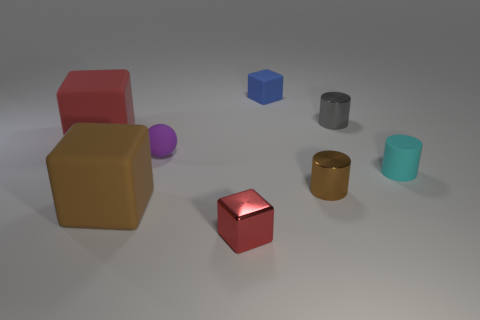There is a large rubber object that is the same color as the small metal block; what shape is it?
Offer a terse response. Cube. There is a matte thing that is the same color as the small metal block; what size is it?
Keep it short and to the point. Large. There is a red object in front of the red rubber object; what is its material?
Offer a terse response. Metal. Is the number of small gray shiny cylinders that are in front of the small purple ball the same as the number of small blocks?
Your answer should be compact. No. Is there any other thing that has the same size as the brown matte cube?
Keep it short and to the point. Yes. There is a brown object that is in front of the cylinder in front of the cyan cylinder; what is its material?
Offer a terse response. Rubber. What is the shape of the tiny matte thing that is both in front of the small rubber block and left of the small cyan thing?
Provide a succinct answer. Sphere. There is another shiny thing that is the same shape as the tiny gray metal object; what is its size?
Offer a terse response. Small. Are there fewer tiny gray cylinders left of the tiny blue thing than red rubber cylinders?
Offer a very short reply. No. There is a red rubber block that is on the left side of the gray cylinder; how big is it?
Your answer should be very brief. Large. 